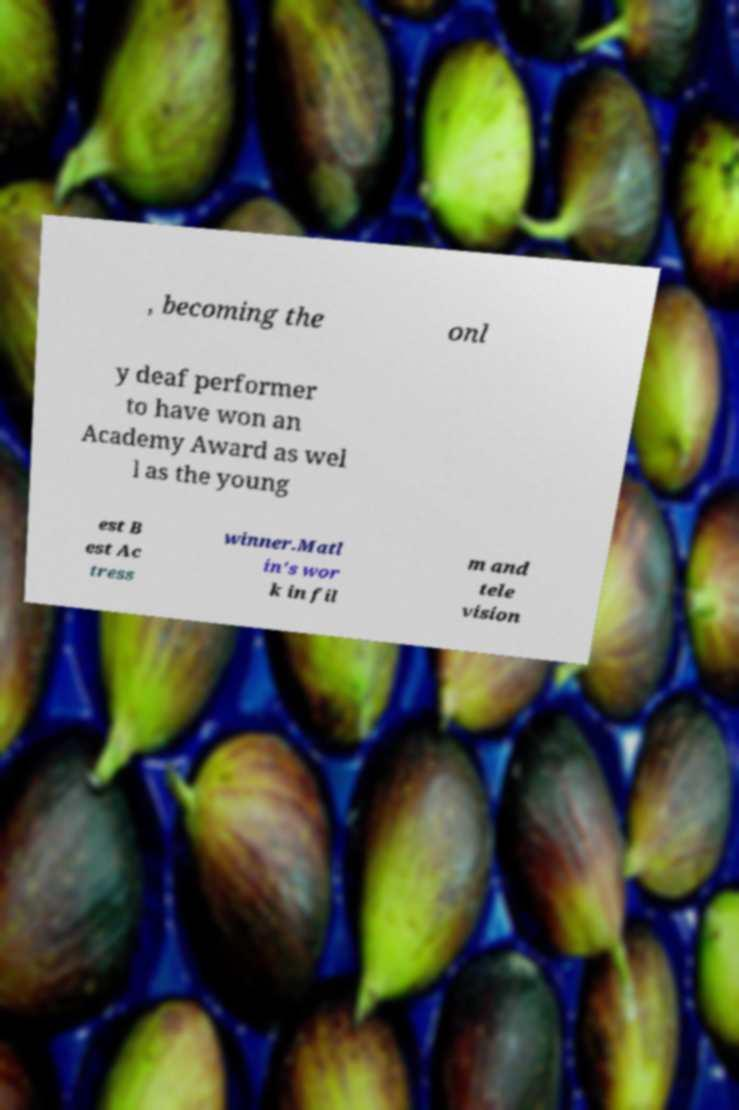Please read and relay the text visible in this image. What does it say? , becoming the onl y deaf performer to have won an Academy Award as wel l as the young est B est Ac tress winner.Matl in's wor k in fil m and tele vision 